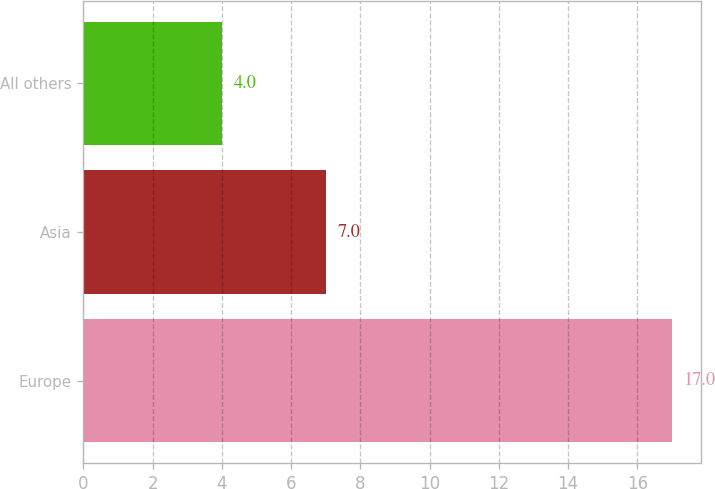Convert chart to OTSL. <chart><loc_0><loc_0><loc_500><loc_500><bar_chart><fcel>Europe<fcel>Asia<fcel>All others<nl><fcel>17<fcel>7<fcel>4<nl></chart> 